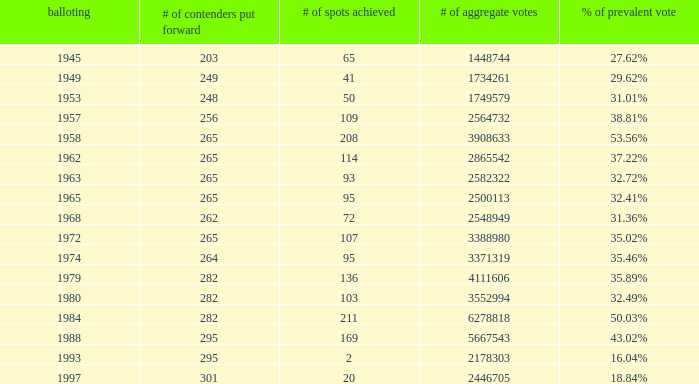How many times was the # of total votes 2582322? 1.0. Would you be able to parse every entry in this table? {'header': ['balloting', '# of contenders put forward', '# of spots achieved', '# of aggregate votes', '% of prevalent vote'], 'rows': [['1945', '203', '65', '1448744', '27.62%'], ['1949', '249', '41', '1734261', '29.62%'], ['1953', '248', '50', '1749579', '31.01%'], ['1957', '256', '109', '2564732', '38.81%'], ['1958', '265', '208', '3908633', '53.56%'], ['1962', '265', '114', '2865542', '37.22%'], ['1963', '265', '93', '2582322', '32.72%'], ['1965', '265', '95', '2500113', '32.41%'], ['1968', '262', '72', '2548949', '31.36%'], ['1972', '265', '107', '3388980', '35.02%'], ['1974', '264', '95', '3371319', '35.46%'], ['1979', '282', '136', '4111606', '35.89%'], ['1980', '282', '103', '3552994', '32.49%'], ['1984', '282', '211', '6278818', '50.03%'], ['1988', '295', '169', '5667543', '43.02%'], ['1993', '295', '2', '2178303', '16.04%'], ['1997', '301', '20', '2446705', '18.84%']]} 